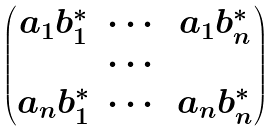Convert formula to latex. <formula><loc_0><loc_0><loc_500><loc_500>\begin{pmatrix} a _ { 1 } b _ { 1 } ^ { * } & \cdots & a _ { 1 } b _ { n } ^ { * } \\ & \cdots & \\ a _ { n } b _ { 1 } ^ { * } & \cdots & a _ { n } b _ { n } ^ { * } \end{pmatrix}</formula> 